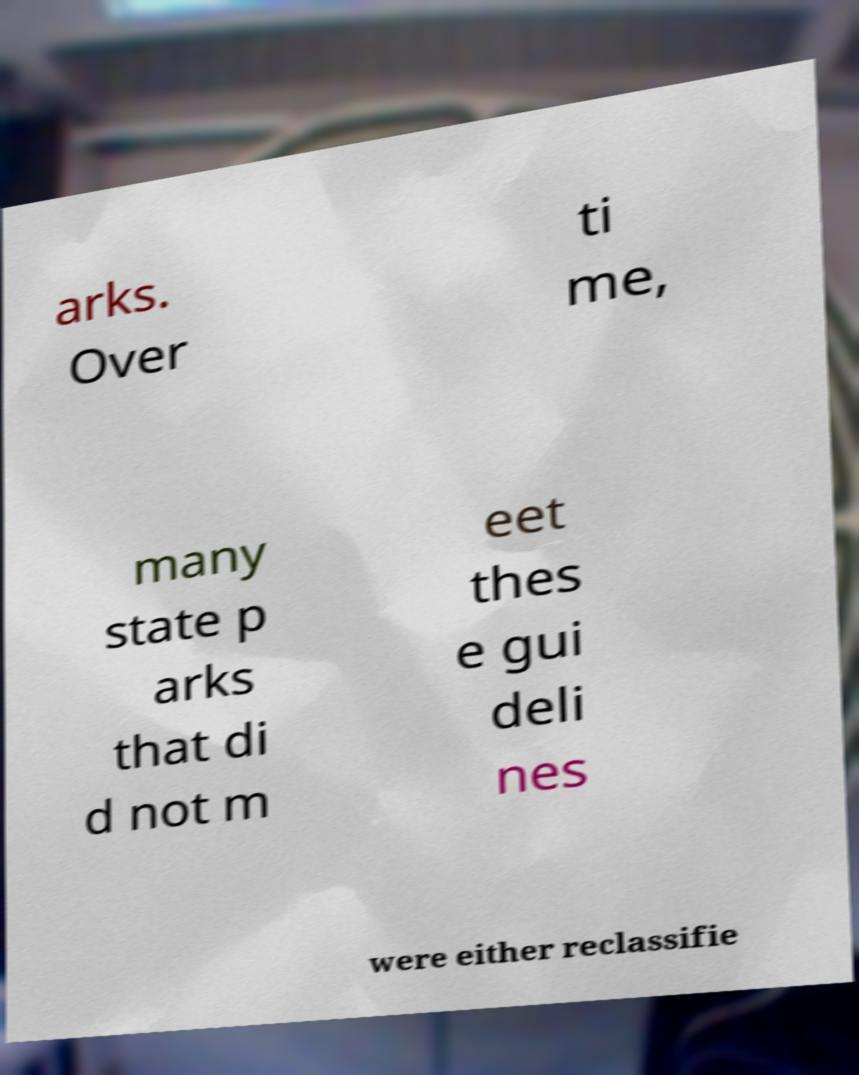Can you read and provide the text displayed in the image?This photo seems to have some interesting text. Can you extract and type it out for me? arks. Over ti me, many state p arks that di d not m eet thes e gui deli nes were either reclassifie 